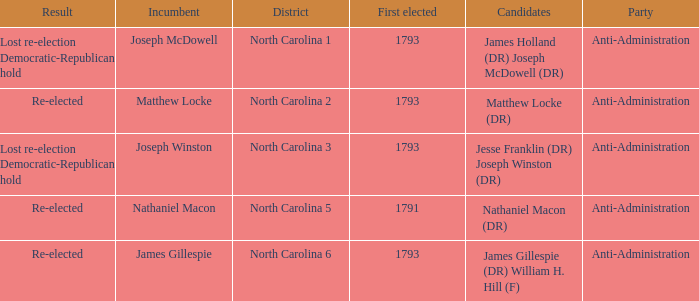Who was the candidate in 1791? Nathaniel Macon (DR). 